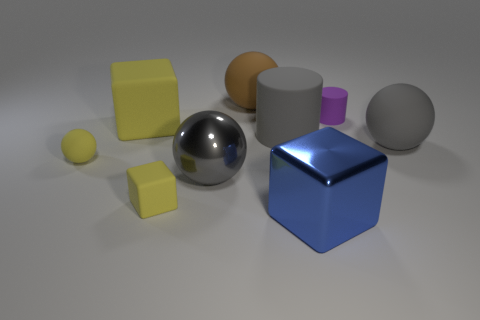Can you infer the possible sizes of these objects? Based on the image, it's challenging to infer the exact sizes without a reference object. However, we can speculate that these are small to medium-sized objects that could be held in one's hand or placed on a desktop, given their relative sizes and the common perception of such geometric shapes. 